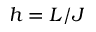Convert formula to latex. <formula><loc_0><loc_0><loc_500><loc_500>h = L / J</formula> 